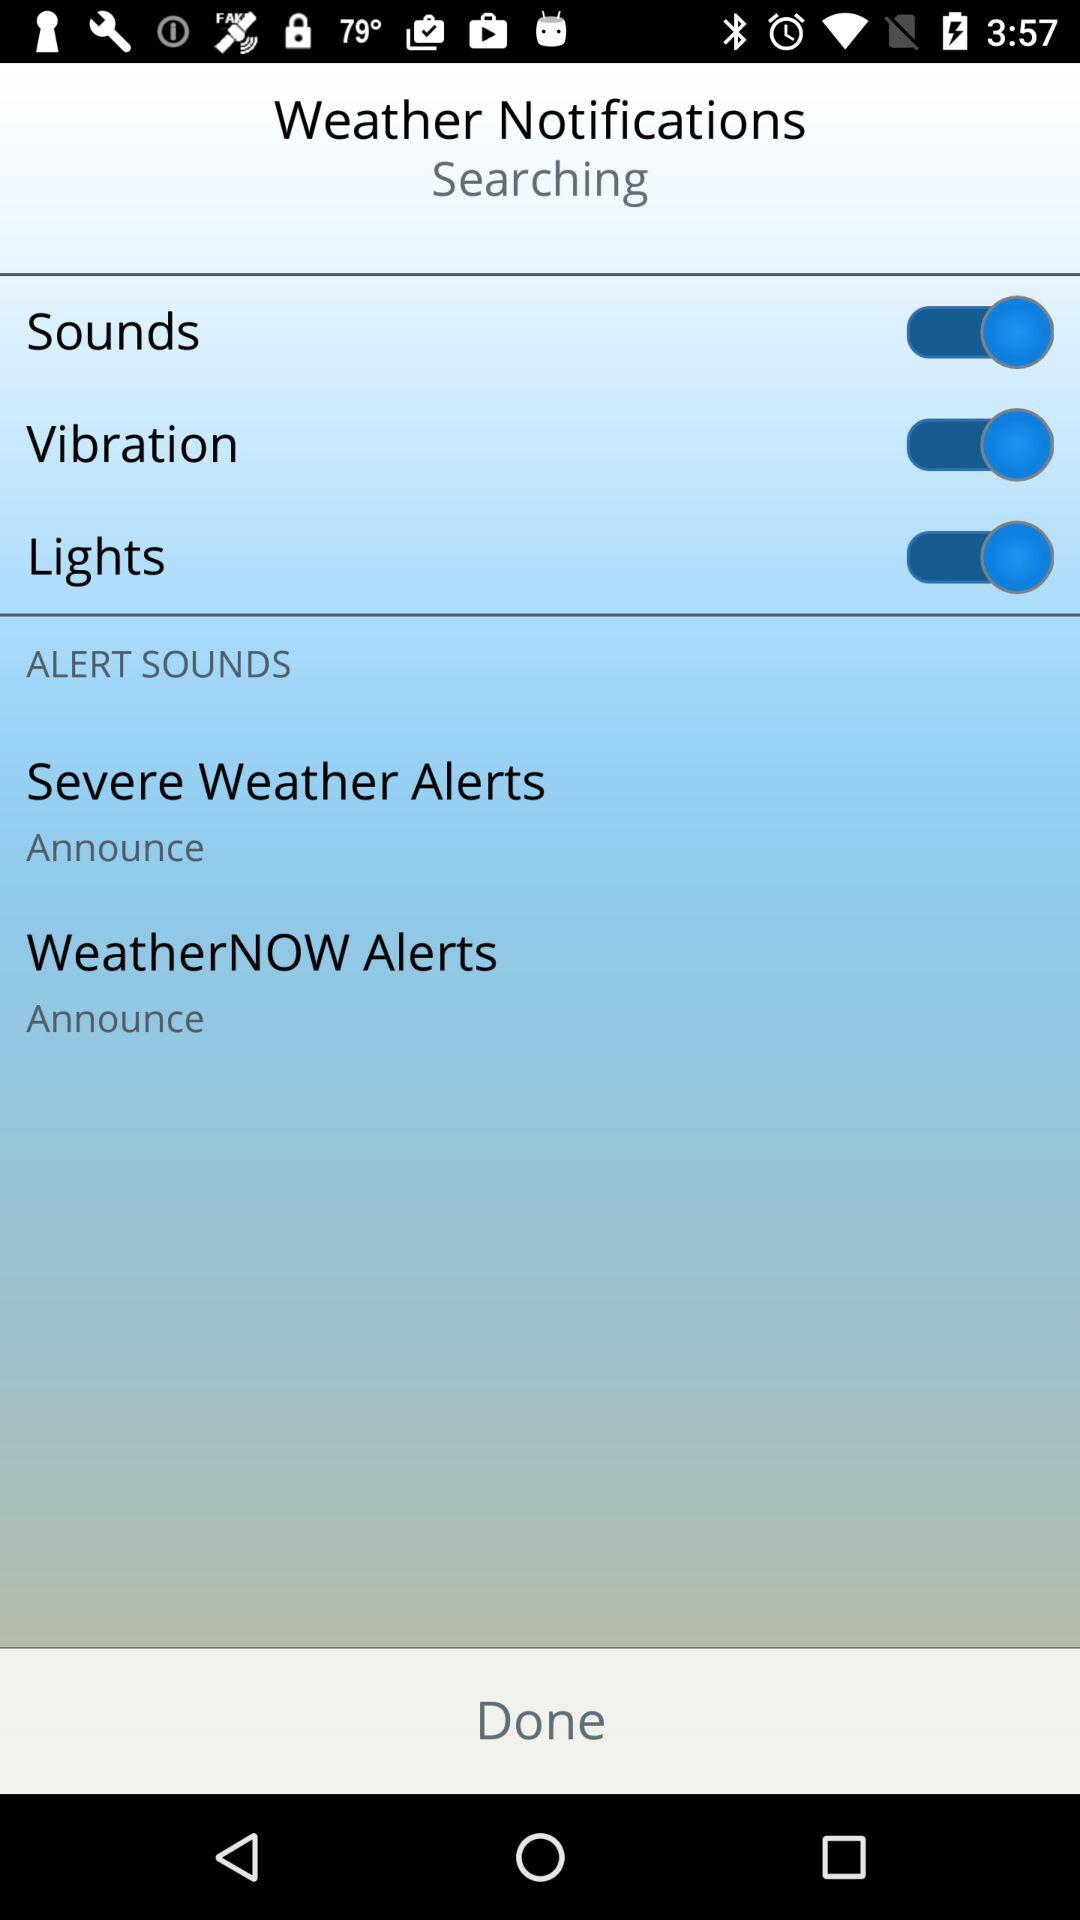What is the status of the "Sounds"? The status of the "Sounds" is "on". 